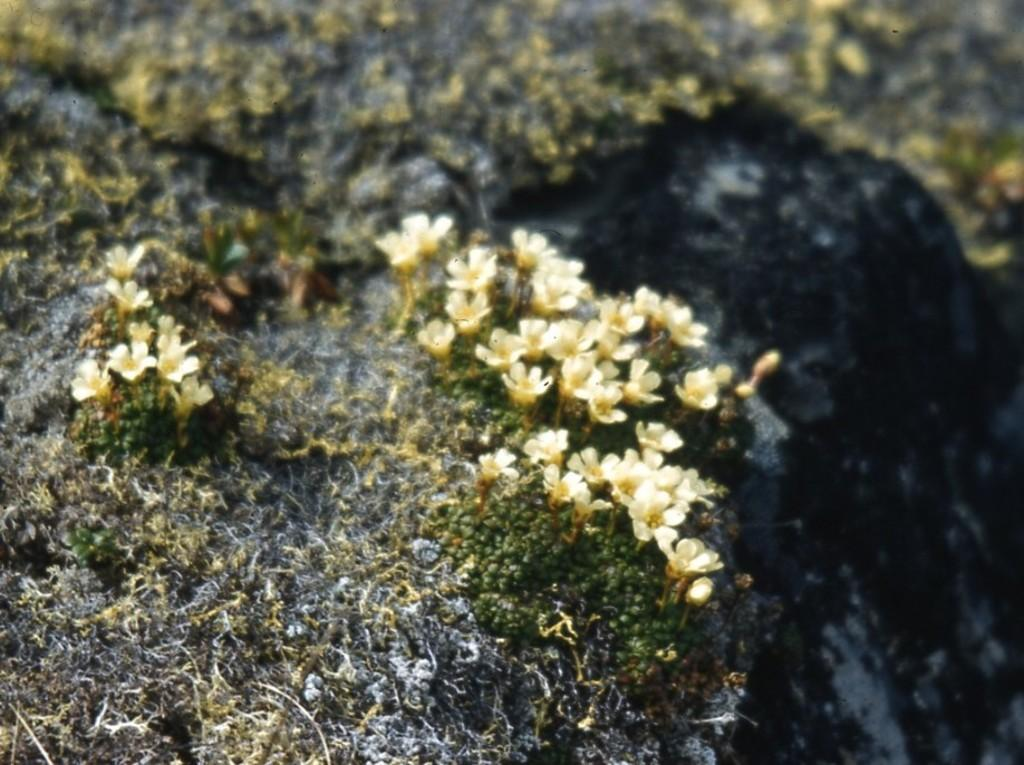What type of flowers are on the rock in the image? There are small white flowers on a rock in the image. What type of vegetation is visible in the image? There is grass visible in the image. What type of religious symbol is present on the rock in the image? There is no religious symbol present on the rock in the image; it features small white flowers. Can you see any guns or weapons in the image? There are no guns or weapons present in the image; it features small white flowers on a rock and grass. Is there a ship visible in the image? There is no ship present in the image; it features small white flowers on a rock and grass. 